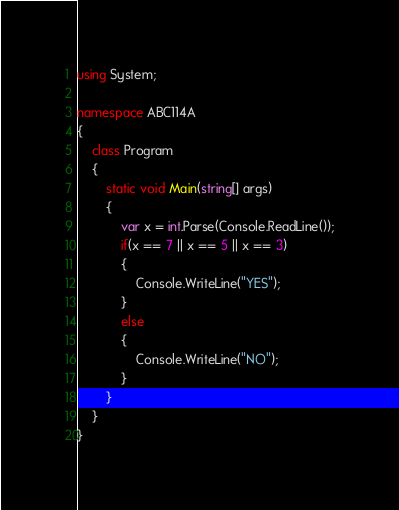<code> <loc_0><loc_0><loc_500><loc_500><_C#_>using System;

namespace ABC114A
{
    class Program
    {
        static void Main(string[] args)
        {
            var x = int.Parse(Console.ReadLine());
            if(x == 7 || x == 5 || x == 3)
            {
                Console.WriteLine("YES");
            }
            else
            {
                Console.WriteLine("NO");
            }
        }
    }
}
</code> 